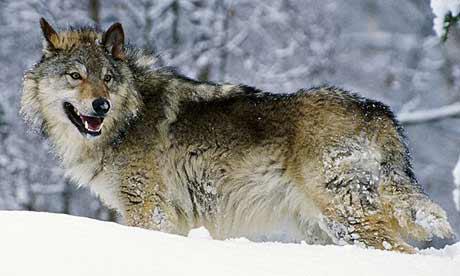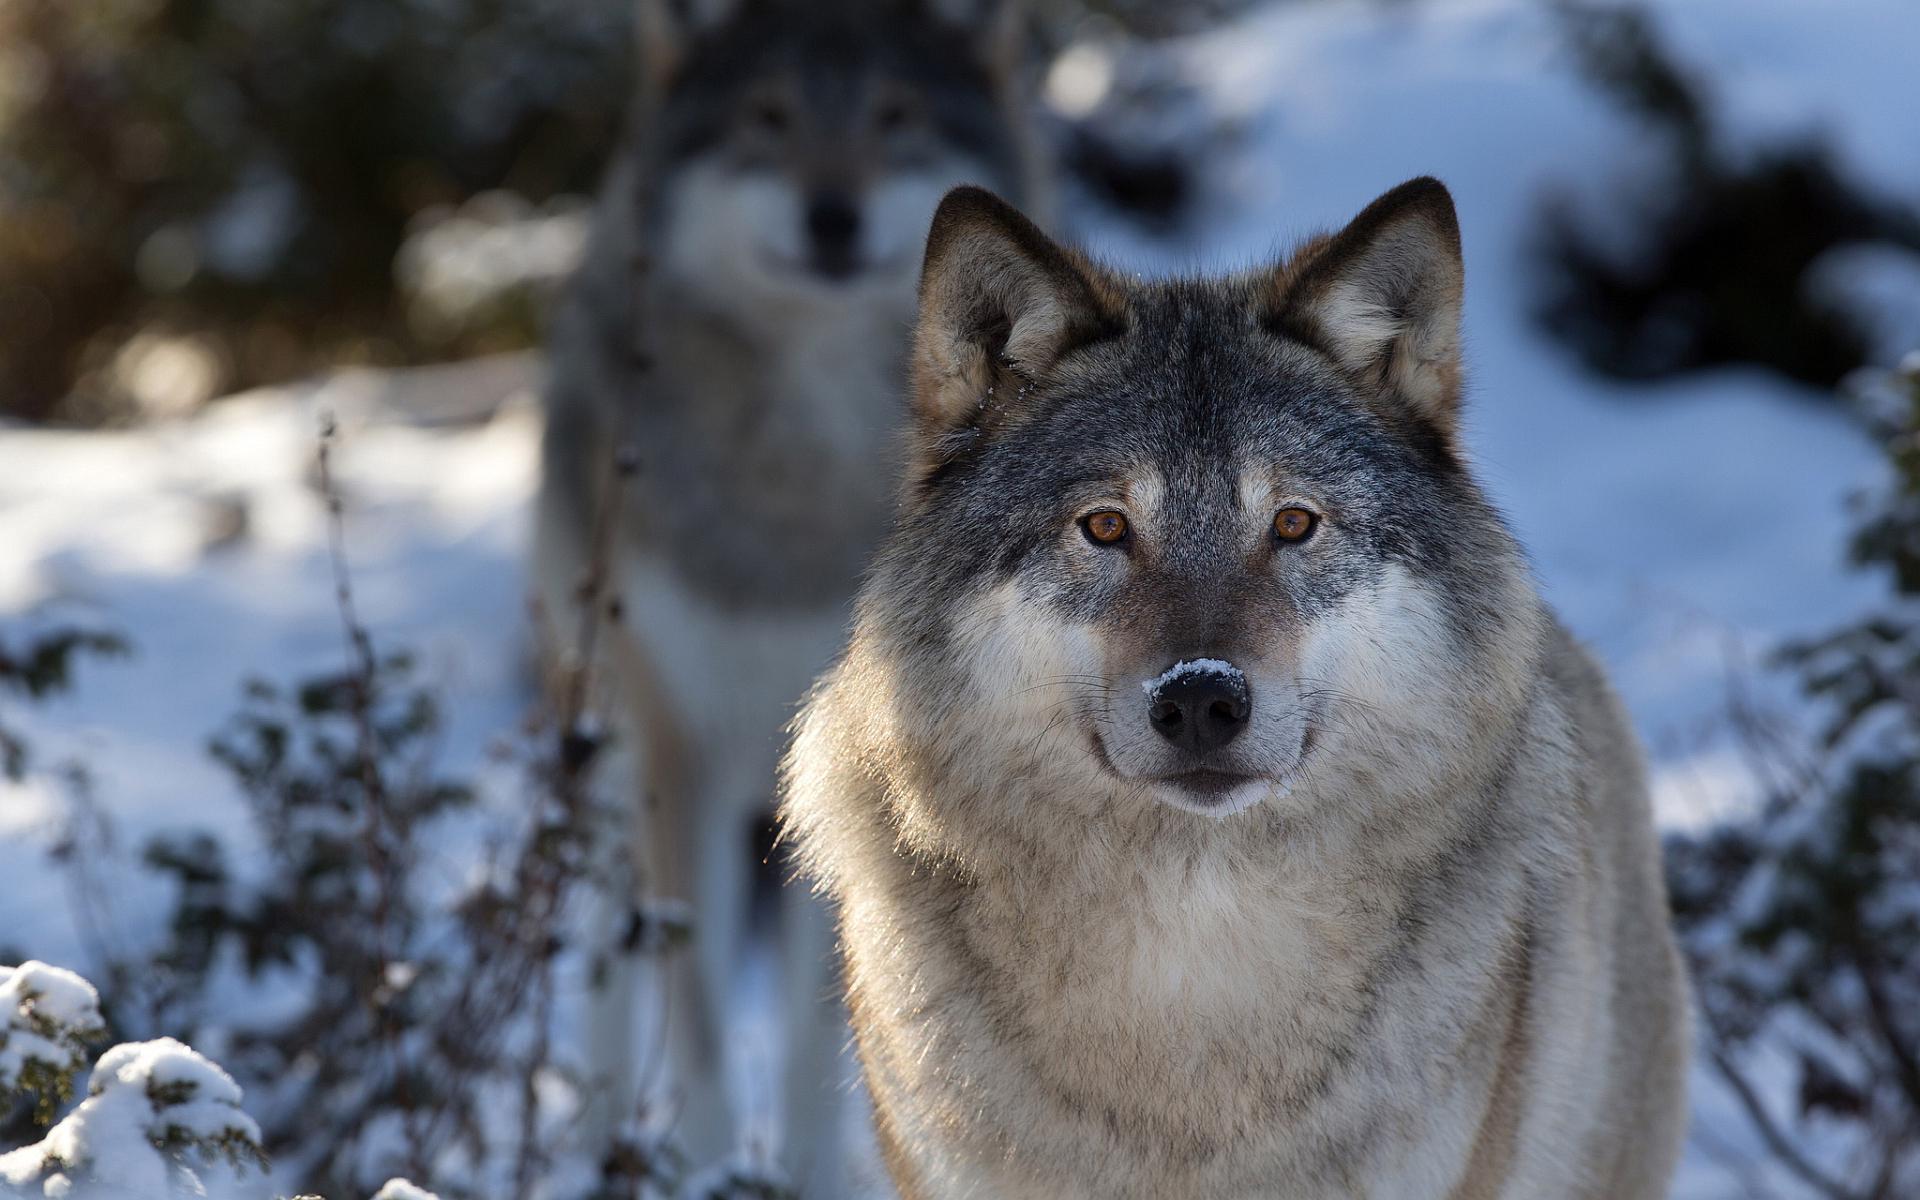The first image is the image on the left, the second image is the image on the right. Evaluate the accuracy of this statement regarding the images: "At least one wolfe has their body positioned toward the right.". Is it true? Answer yes or no. No. 